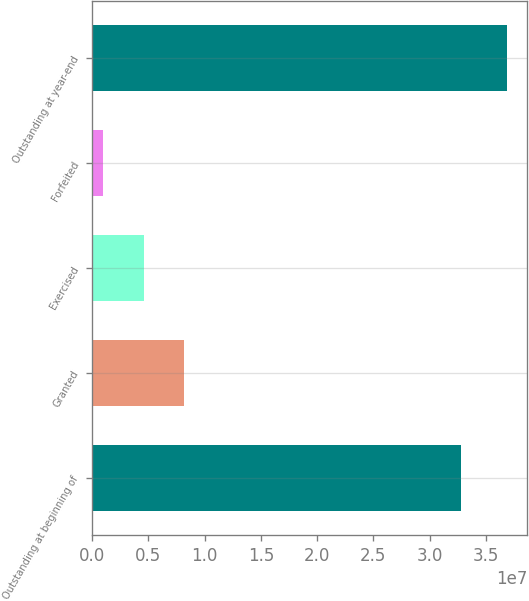Convert chart to OTSL. <chart><loc_0><loc_0><loc_500><loc_500><bar_chart><fcel>Outstanding at beginning of<fcel>Granted<fcel>Exercised<fcel>Forfeited<fcel>Outstanding at year-end<nl><fcel>3.28363e+07<fcel>8.16168e+06<fcel>4.57318e+06<fcel>984680<fcel>3.68697e+07<nl></chart> 